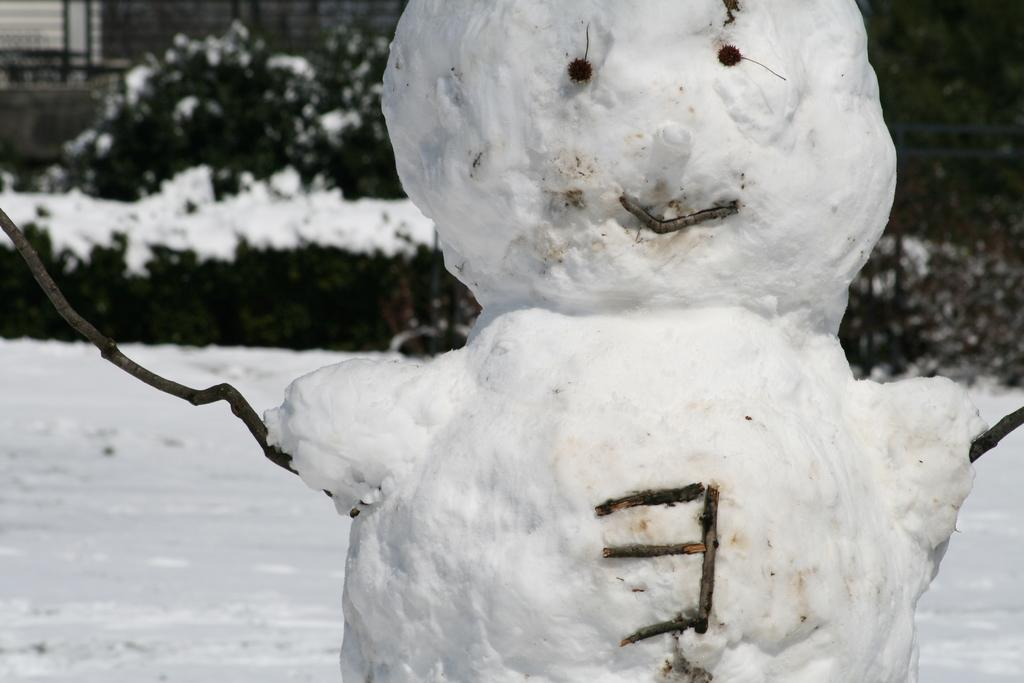What is the main subject in the image? There is a snowman in the image. What can be seen in the background of the image? There are plants covered with snow in the background. Where is the window located in the image? There is a wall with a window in the left top part of the image. How many sticks are being used by the flock of birds in the image? There are no birds or sticks present in the image. 